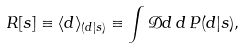Convert formula to latex. <formula><loc_0><loc_0><loc_500><loc_500>R [ s ] \equiv \langle d \rangle _ { ( d | s ) } \equiv \int \mathcal { D } d \, d \, P ( d | s ) ,</formula> 